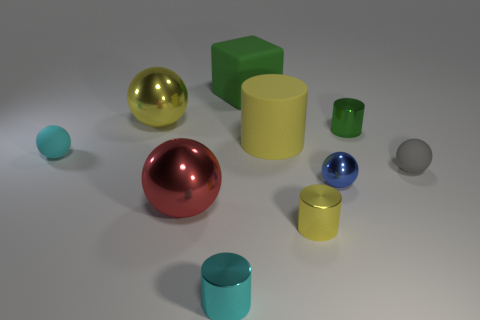Can you tell me how many objects are there in total? Certainly, in total, there are eleven objects scattered throughout the image. 